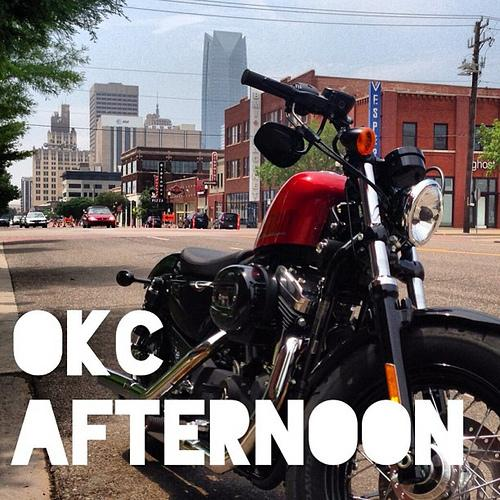Give a brief summary of the overall scene in the image. The image captures a street scene in the central part of a city with multiple buildings, a tall skyscraper, a wooden electrical pole, and parked vehicles, including red and gray cars, and a red motorcycle. Describe the building on the corner of the image and provide as many details as possible. The building on the corner is a reddish brick building that is made of bricks and has several windows. It appears to be a part of the central part of the city What kind of weather can be inferred from the image? The weather can be inferred as overcast. Estimate the number of windows visible on the brick buildings in the image. There are at least 6 windows visible on the brick buildings. Enumerate the different objects found in this image with their respective counts. There are 1 tall building, multiple buildings, 1 store name, 1 wooden electrical pole, 2 power line posts, electrical lines, 1 small red car, 1 gray sedan car, 1 tall blue and white sign, 1 red motorcycle, 2 cars parked on meters, windows on brick buildings, 1 tree overhanging the road, trees at the back, leaves, and motorcycle parts. Comment on the structural design of the tall building in the image. The tall building has a glass façade and appears to be a modern skyscraper. Identify the color and type of the car parked to the left of the motorcycle. The car is red and it is a sedan. Describe the condition of the motorcycle's headlight and any other noticeable features. The headlight on the parked motorcycle is on, and it has chrome spokes on the tire, black seat, and silver pipes. Examine the condition of the leaves of the tree in the image. The leaves of the tree appear to be green and healthy. Describe the relationship between the electrical lines and their support structures in the image. The electrical lines are suspended in the air by wooden electrical poles and power line posts. 